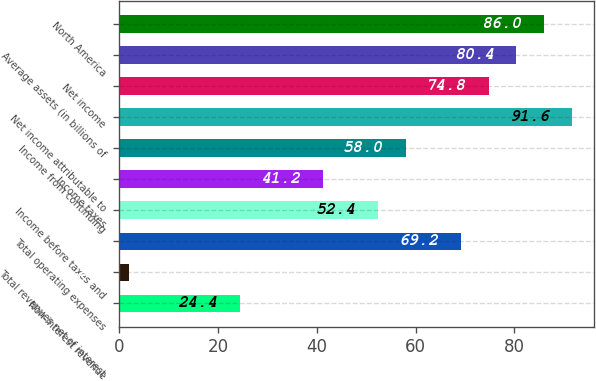Convert chart to OTSL. <chart><loc_0><loc_0><loc_500><loc_500><bar_chart><fcel>Non-interest revenue<fcel>Total revenues net of interest<fcel>Total operating expenses<fcel>Income before taxes and<fcel>Income taxes<fcel>Income from continuing<fcel>Net income attributable to<fcel>Net income<fcel>Average assets (in billions of<fcel>North America<nl><fcel>24.4<fcel>2<fcel>69.2<fcel>52.4<fcel>41.2<fcel>58<fcel>91.6<fcel>74.8<fcel>80.4<fcel>86<nl></chart> 